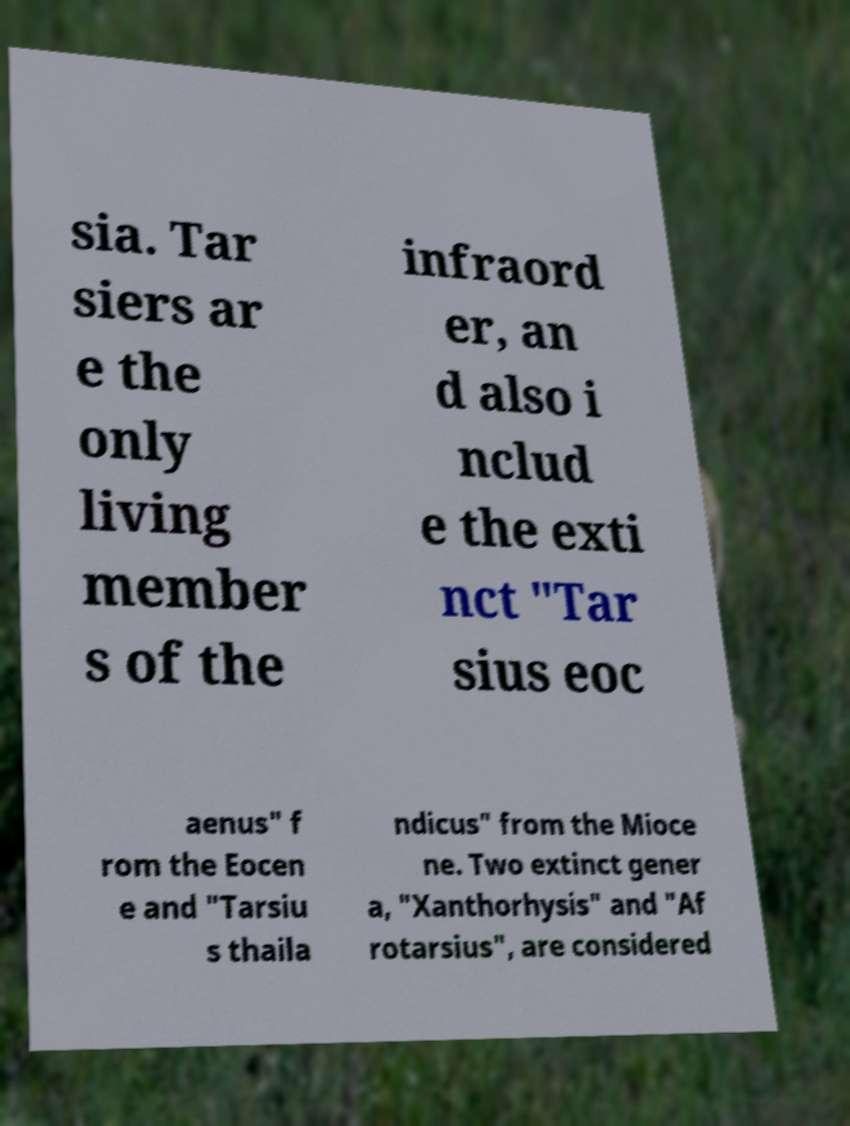Can you read and provide the text displayed in the image?This photo seems to have some interesting text. Can you extract and type it out for me? sia. Tar siers ar e the only living member s of the infraord er, an d also i nclud e the exti nct "Tar sius eoc aenus" f rom the Eocen e and "Tarsiu s thaila ndicus" from the Mioce ne. Two extinct gener a, "Xanthorhysis" and "Af rotarsius", are considered 